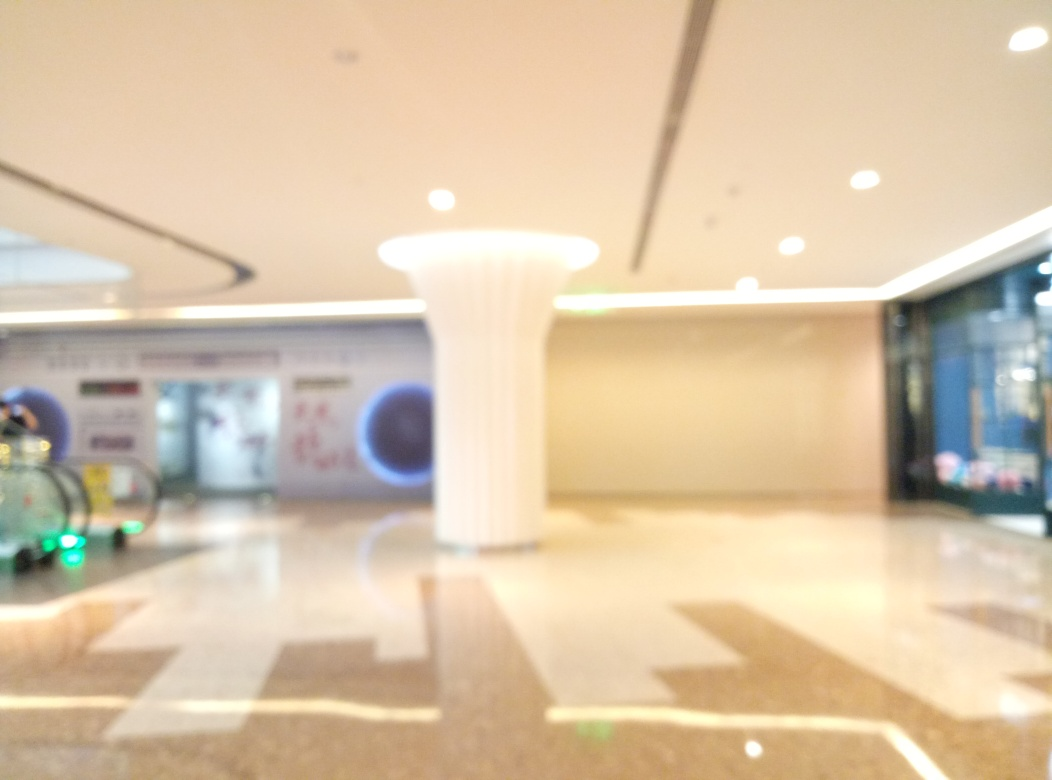Does the image look sharp?
A. No
B. Yes
Answer with the option's letter from the given choices directly.
 A. 